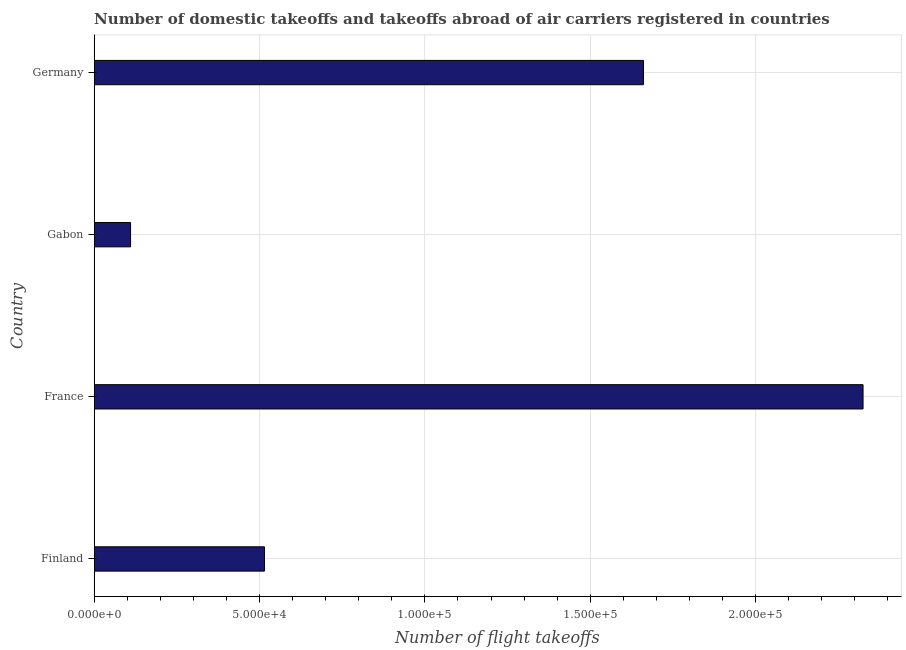Does the graph contain any zero values?
Ensure brevity in your answer.  No. Does the graph contain grids?
Your response must be concise. Yes. What is the title of the graph?
Provide a succinct answer. Number of domestic takeoffs and takeoffs abroad of air carriers registered in countries. What is the label or title of the X-axis?
Give a very brief answer. Number of flight takeoffs. What is the label or title of the Y-axis?
Ensure brevity in your answer.  Country. What is the number of flight takeoffs in Gabon?
Offer a terse response. 1.10e+04. Across all countries, what is the maximum number of flight takeoffs?
Make the answer very short. 2.32e+05. Across all countries, what is the minimum number of flight takeoffs?
Give a very brief answer. 1.10e+04. In which country was the number of flight takeoffs maximum?
Your answer should be compact. France. In which country was the number of flight takeoffs minimum?
Your answer should be very brief. Gabon. What is the sum of the number of flight takeoffs?
Your answer should be compact. 4.61e+05. What is the difference between the number of flight takeoffs in Finland and Germany?
Your response must be concise. -1.15e+05. What is the average number of flight takeoffs per country?
Provide a succinct answer. 1.15e+05. What is the median number of flight takeoffs?
Ensure brevity in your answer.  1.09e+05. In how many countries, is the number of flight takeoffs greater than 230000 ?
Provide a short and direct response. 1. What is the ratio of the number of flight takeoffs in Finland to that in France?
Offer a very short reply. 0.22. Is the number of flight takeoffs in France less than that in Gabon?
Your response must be concise. No. Is the difference between the number of flight takeoffs in Finland and France greater than the difference between any two countries?
Your answer should be very brief. No. What is the difference between the highest and the second highest number of flight takeoffs?
Provide a short and direct response. 6.64e+04. What is the difference between the highest and the lowest number of flight takeoffs?
Your answer should be compact. 2.22e+05. In how many countries, is the number of flight takeoffs greater than the average number of flight takeoffs taken over all countries?
Keep it short and to the point. 2. How many bars are there?
Your answer should be compact. 4. Are all the bars in the graph horizontal?
Provide a succinct answer. Yes. Are the values on the major ticks of X-axis written in scientific E-notation?
Your response must be concise. Yes. What is the Number of flight takeoffs of Finland?
Offer a very short reply. 5.15e+04. What is the Number of flight takeoffs in France?
Offer a very short reply. 2.32e+05. What is the Number of flight takeoffs in Gabon?
Give a very brief answer. 1.10e+04. What is the Number of flight takeoffs of Germany?
Your response must be concise. 1.66e+05. What is the difference between the Number of flight takeoffs in Finland and France?
Provide a short and direct response. -1.81e+05. What is the difference between the Number of flight takeoffs in Finland and Gabon?
Ensure brevity in your answer.  4.05e+04. What is the difference between the Number of flight takeoffs in Finland and Germany?
Your response must be concise. -1.15e+05. What is the difference between the Number of flight takeoffs in France and Gabon?
Provide a succinct answer. 2.22e+05. What is the difference between the Number of flight takeoffs in France and Germany?
Your answer should be very brief. 6.64e+04. What is the difference between the Number of flight takeoffs in Gabon and Germany?
Your response must be concise. -1.55e+05. What is the ratio of the Number of flight takeoffs in Finland to that in France?
Give a very brief answer. 0.22. What is the ratio of the Number of flight takeoffs in Finland to that in Gabon?
Your answer should be compact. 4.68. What is the ratio of the Number of flight takeoffs in Finland to that in Germany?
Offer a very short reply. 0.31. What is the ratio of the Number of flight takeoffs in France to that in Gabon?
Ensure brevity in your answer.  21.14. What is the ratio of the Number of flight takeoffs in France to that in Germany?
Offer a very short reply. 1.4. What is the ratio of the Number of flight takeoffs in Gabon to that in Germany?
Offer a terse response. 0.07. 